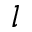Convert formula to latex. <formula><loc_0><loc_0><loc_500><loc_500>l</formula> 